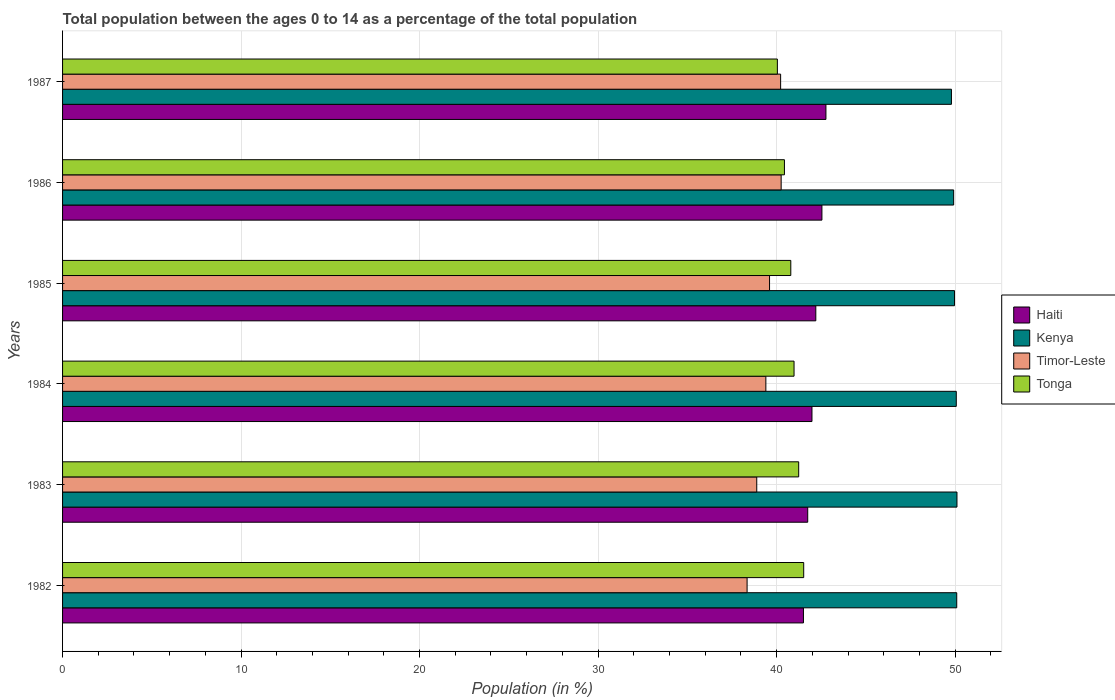How many different coloured bars are there?
Offer a very short reply. 4. How many groups of bars are there?
Make the answer very short. 6. What is the label of the 4th group of bars from the top?
Provide a succinct answer. 1984. In how many cases, is the number of bars for a given year not equal to the number of legend labels?
Your answer should be very brief. 0. What is the percentage of the population ages 0 to 14 in Timor-Leste in 1982?
Keep it short and to the point. 38.35. Across all years, what is the maximum percentage of the population ages 0 to 14 in Tonga?
Offer a terse response. 41.52. Across all years, what is the minimum percentage of the population ages 0 to 14 in Timor-Leste?
Offer a very short reply. 38.35. What is the total percentage of the population ages 0 to 14 in Kenya in the graph?
Keep it short and to the point. 299.94. What is the difference between the percentage of the population ages 0 to 14 in Kenya in 1986 and that in 1987?
Keep it short and to the point. 0.12. What is the difference between the percentage of the population ages 0 to 14 in Tonga in 1987 and the percentage of the population ages 0 to 14 in Kenya in 1985?
Ensure brevity in your answer.  -9.92. What is the average percentage of the population ages 0 to 14 in Timor-Leste per year?
Provide a short and direct response. 39.45. In the year 1984, what is the difference between the percentage of the population ages 0 to 14 in Tonga and percentage of the population ages 0 to 14 in Haiti?
Keep it short and to the point. -1. What is the ratio of the percentage of the population ages 0 to 14 in Kenya in 1984 to that in 1987?
Your answer should be compact. 1.01. Is the percentage of the population ages 0 to 14 in Tonga in 1984 less than that in 1986?
Your answer should be very brief. No. What is the difference between the highest and the second highest percentage of the population ages 0 to 14 in Tonga?
Offer a terse response. 0.28. What is the difference between the highest and the lowest percentage of the population ages 0 to 14 in Timor-Leste?
Give a very brief answer. 1.91. In how many years, is the percentage of the population ages 0 to 14 in Tonga greater than the average percentage of the population ages 0 to 14 in Tonga taken over all years?
Provide a succinct answer. 3. Is the sum of the percentage of the population ages 0 to 14 in Timor-Leste in 1984 and 1985 greater than the maximum percentage of the population ages 0 to 14 in Tonga across all years?
Offer a very short reply. Yes. What does the 4th bar from the top in 1987 represents?
Your answer should be compact. Haiti. What does the 1st bar from the bottom in 1984 represents?
Give a very brief answer. Haiti. How many years are there in the graph?
Ensure brevity in your answer.  6. Does the graph contain grids?
Your answer should be compact. Yes. Where does the legend appear in the graph?
Your answer should be compact. Center right. What is the title of the graph?
Your response must be concise. Total population between the ages 0 to 14 as a percentage of the total population. Does "Latvia" appear as one of the legend labels in the graph?
Make the answer very short. No. What is the label or title of the X-axis?
Your response must be concise. Population (in %). What is the Population (in %) in Haiti in 1982?
Your answer should be compact. 41.5. What is the Population (in %) in Kenya in 1982?
Your response must be concise. 50.09. What is the Population (in %) of Timor-Leste in 1982?
Keep it short and to the point. 38.35. What is the Population (in %) in Tonga in 1982?
Offer a terse response. 41.52. What is the Population (in %) in Haiti in 1983?
Ensure brevity in your answer.  41.74. What is the Population (in %) in Kenya in 1983?
Your answer should be compact. 50.1. What is the Population (in %) of Timor-Leste in 1983?
Offer a very short reply. 38.89. What is the Population (in %) of Tonga in 1983?
Ensure brevity in your answer.  41.24. What is the Population (in %) in Haiti in 1984?
Offer a terse response. 41.98. What is the Population (in %) of Kenya in 1984?
Make the answer very short. 50.07. What is the Population (in %) in Timor-Leste in 1984?
Your answer should be compact. 39.4. What is the Population (in %) of Tonga in 1984?
Your answer should be compact. 40.98. What is the Population (in %) of Haiti in 1985?
Offer a terse response. 42.2. What is the Population (in %) of Kenya in 1985?
Give a very brief answer. 49.97. What is the Population (in %) in Timor-Leste in 1985?
Your response must be concise. 39.6. What is the Population (in %) in Tonga in 1985?
Your answer should be very brief. 40.79. What is the Population (in %) of Haiti in 1986?
Keep it short and to the point. 42.54. What is the Population (in %) in Kenya in 1986?
Give a very brief answer. 49.92. What is the Population (in %) in Timor-Leste in 1986?
Give a very brief answer. 40.26. What is the Population (in %) in Tonga in 1986?
Your response must be concise. 40.44. What is the Population (in %) in Haiti in 1987?
Offer a very short reply. 42.76. What is the Population (in %) in Kenya in 1987?
Provide a succinct answer. 49.79. What is the Population (in %) in Timor-Leste in 1987?
Provide a succinct answer. 40.23. What is the Population (in %) in Tonga in 1987?
Your answer should be very brief. 40.04. Across all years, what is the maximum Population (in %) of Haiti?
Ensure brevity in your answer.  42.76. Across all years, what is the maximum Population (in %) in Kenya?
Provide a short and direct response. 50.1. Across all years, what is the maximum Population (in %) of Timor-Leste?
Give a very brief answer. 40.26. Across all years, what is the maximum Population (in %) of Tonga?
Your answer should be compact. 41.52. Across all years, what is the minimum Population (in %) in Haiti?
Give a very brief answer. 41.5. Across all years, what is the minimum Population (in %) in Kenya?
Ensure brevity in your answer.  49.79. Across all years, what is the minimum Population (in %) in Timor-Leste?
Provide a short and direct response. 38.35. Across all years, what is the minimum Population (in %) of Tonga?
Keep it short and to the point. 40.04. What is the total Population (in %) of Haiti in the graph?
Give a very brief answer. 252.73. What is the total Population (in %) in Kenya in the graph?
Provide a short and direct response. 299.94. What is the total Population (in %) of Timor-Leste in the graph?
Offer a terse response. 236.72. What is the total Population (in %) of Tonga in the graph?
Provide a short and direct response. 245.01. What is the difference between the Population (in %) of Haiti in 1982 and that in 1983?
Provide a succinct answer. -0.24. What is the difference between the Population (in %) in Kenya in 1982 and that in 1983?
Give a very brief answer. -0.01. What is the difference between the Population (in %) of Timor-Leste in 1982 and that in 1983?
Your response must be concise. -0.54. What is the difference between the Population (in %) in Tonga in 1982 and that in 1983?
Give a very brief answer. 0.28. What is the difference between the Population (in %) of Haiti in 1982 and that in 1984?
Keep it short and to the point. -0.48. What is the difference between the Population (in %) in Kenya in 1982 and that in 1984?
Keep it short and to the point. 0.03. What is the difference between the Population (in %) in Timor-Leste in 1982 and that in 1984?
Offer a very short reply. -1.05. What is the difference between the Population (in %) in Tonga in 1982 and that in 1984?
Keep it short and to the point. 0.54. What is the difference between the Population (in %) in Haiti in 1982 and that in 1985?
Make the answer very short. -0.69. What is the difference between the Population (in %) in Kenya in 1982 and that in 1985?
Offer a very short reply. 0.12. What is the difference between the Population (in %) in Timor-Leste in 1982 and that in 1985?
Offer a very short reply. -1.26. What is the difference between the Population (in %) in Tonga in 1982 and that in 1985?
Make the answer very short. 0.72. What is the difference between the Population (in %) of Haiti in 1982 and that in 1986?
Your answer should be very brief. -1.03. What is the difference between the Population (in %) of Kenya in 1982 and that in 1986?
Offer a terse response. 0.17. What is the difference between the Population (in %) of Timor-Leste in 1982 and that in 1986?
Your response must be concise. -1.91. What is the difference between the Population (in %) of Tonga in 1982 and that in 1986?
Ensure brevity in your answer.  1.08. What is the difference between the Population (in %) of Haiti in 1982 and that in 1987?
Provide a succinct answer. -1.26. What is the difference between the Population (in %) in Kenya in 1982 and that in 1987?
Give a very brief answer. 0.3. What is the difference between the Population (in %) in Timor-Leste in 1982 and that in 1987?
Your answer should be compact. -1.88. What is the difference between the Population (in %) of Tonga in 1982 and that in 1987?
Provide a short and direct response. 1.47. What is the difference between the Population (in %) of Haiti in 1983 and that in 1984?
Keep it short and to the point. -0.24. What is the difference between the Population (in %) in Kenya in 1983 and that in 1984?
Your answer should be compact. 0.04. What is the difference between the Population (in %) in Timor-Leste in 1983 and that in 1984?
Provide a succinct answer. -0.51. What is the difference between the Population (in %) of Tonga in 1983 and that in 1984?
Keep it short and to the point. 0.26. What is the difference between the Population (in %) in Haiti in 1983 and that in 1985?
Give a very brief answer. -0.45. What is the difference between the Population (in %) in Kenya in 1983 and that in 1985?
Your answer should be compact. 0.14. What is the difference between the Population (in %) of Timor-Leste in 1983 and that in 1985?
Ensure brevity in your answer.  -0.72. What is the difference between the Population (in %) in Tonga in 1983 and that in 1985?
Give a very brief answer. 0.44. What is the difference between the Population (in %) of Haiti in 1983 and that in 1986?
Give a very brief answer. -0.79. What is the difference between the Population (in %) of Kenya in 1983 and that in 1986?
Provide a short and direct response. 0.19. What is the difference between the Population (in %) of Timor-Leste in 1983 and that in 1986?
Your response must be concise. -1.37. What is the difference between the Population (in %) in Tonga in 1983 and that in 1986?
Your answer should be very brief. 0.8. What is the difference between the Population (in %) in Haiti in 1983 and that in 1987?
Your answer should be very brief. -1.02. What is the difference between the Population (in %) in Kenya in 1983 and that in 1987?
Provide a succinct answer. 0.31. What is the difference between the Population (in %) of Timor-Leste in 1983 and that in 1987?
Offer a very short reply. -1.34. What is the difference between the Population (in %) in Tonga in 1983 and that in 1987?
Provide a succinct answer. 1.19. What is the difference between the Population (in %) in Haiti in 1984 and that in 1985?
Offer a terse response. -0.21. What is the difference between the Population (in %) of Kenya in 1984 and that in 1985?
Your answer should be very brief. 0.1. What is the difference between the Population (in %) of Timor-Leste in 1984 and that in 1985?
Ensure brevity in your answer.  -0.21. What is the difference between the Population (in %) in Tonga in 1984 and that in 1985?
Keep it short and to the point. 0.18. What is the difference between the Population (in %) of Haiti in 1984 and that in 1986?
Offer a terse response. -0.56. What is the difference between the Population (in %) of Kenya in 1984 and that in 1986?
Make the answer very short. 0.15. What is the difference between the Population (in %) in Timor-Leste in 1984 and that in 1986?
Provide a succinct answer. -0.86. What is the difference between the Population (in %) of Tonga in 1984 and that in 1986?
Make the answer very short. 0.54. What is the difference between the Population (in %) of Haiti in 1984 and that in 1987?
Make the answer very short. -0.78. What is the difference between the Population (in %) of Kenya in 1984 and that in 1987?
Offer a very short reply. 0.27. What is the difference between the Population (in %) of Timor-Leste in 1984 and that in 1987?
Your response must be concise. -0.83. What is the difference between the Population (in %) of Tonga in 1984 and that in 1987?
Provide a short and direct response. 0.93. What is the difference between the Population (in %) in Haiti in 1985 and that in 1986?
Make the answer very short. -0.34. What is the difference between the Population (in %) in Kenya in 1985 and that in 1986?
Provide a succinct answer. 0.05. What is the difference between the Population (in %) in Timor-Leste in 1985 and that in 1986?
Provide a short and direct response. -0.65. What is the difference between the Population (in %) in Tonga in 1985 and that in 1986?
Keep it short and to the point. 0.36. What is the difference between the Population (in %) of Haiti in 1985 and that in 1987?
Ensure brevity in your answer.  -0.57. What is the difference between the Population (in %) in Kenya in 1985 and that in 1987?
Your answer should be very brief. 0.17. What is the difference between the Population (in %) of Timor-Leste in 1985 and that in 1987?
Ensure brevity in your answer.  -0.62. What is the difference between the Population (in %) in Tonga in 1985 and that in 1987?
Your response must be concise. 0.75. What is the difference between the Population (in %) of Haiti in 1986 and that in 1987?
Offer a terse response. -0.23. What is the difference between the Population (in %) in Kenya in 1986 and that in 1987?
Offer a very short reply. 0.12. What is the difference between the Population (in %) in Timor-Leste in 1986 and that in 1987?
Offer a terse response. 0.03. What is the difference between the Population (in %) of Tonga in 1986 and that in 1987?
Make the answer very short. 0.4. What is the difference between the Population (in %) of Haiti in 1982 and the Population (in %) of Kenya in 1983?
Your response must be concise. -8.6. What is the difference between the Population (in %) of Haiti in 1982 and the Population (in %) of Timor-Leste in 1983?
Provide a succinct answer. 2.62. What is the difference between the Population (in %) of Haiti in 1982 and the Population (in %) of Tonga in 1983?
Your answer should be compact. 0.27. What is the difference between the Population (in %) of Kenya in 1982 and the Population (in %) of Timor-Leste in 1983?
Make the answer very short. 11.2. What is the difference between the Population (in %) in Kenya in 1982 and the Population (in %) in Tonga in 1983?
Your response must be concise. 8.85. What is the difference between the Population (in %) of Timor-Leste in 1982 and the Population (in %) of Tonga in 1983?
Your answer should be compact. -2.89. What is the difference between the Population (in %) of Haiti in 1982 and the Population (in %) of Kenya in 1984?
Make the answer very short. -8.56. What is the difference between the Population (in %) of Haiti in 1982 and the Population (in %) of Timor-Leste in 1984?
Provide a succinct answer. 2.11. What is the difference between the Population (in %) in Haiti in 1982 and the Population (in %) in Tonga in 1984?
Your response must be concise. 0.53. What is the difference between the Population (in %) in Kenya in 1982 and the Population (in %) in Timor-Leste in 1984?
Keep it short and to the point. 10.69. What is the difference between the Population (in %) of Kenya in 1982 and the Population (in %) of Tonga in 1984?
Keep it short and to the point. 9.11. What is the difference between the Population (in %) of Timor-Leste in 1982 and the Population (in %) of Tonga in 1984?
Your answer should be compact. -2.63. What is the difference between the Population (in %) of Haiti in 1982 and the Population (in %) of Kenya in 1985?
Make the answer very short. -8.46. What is the difference between the Population (in %) in Haiti in 1982 and the Population (in %) in Timor-Leste in 1985?
Your response must be concise. 1.9. What is the difference between the Population (in %) of Haiti in 1982 and the Population (in %) of Tonga in 1985?
Offer a terse response. 0.71. What is the difference between the Population (in %) in Kenya in 1982 and the Population (in %) in Timor-Leste in 1985?
Offer a very short reply. 10.49. What is the difference between the Population (in %) in Kenya in 1982 and the Population (in %) in Tonga in 1985?
Offer a terse response. 9.3. What is the difference between the Population (in %) in Timor-Leste in 1982 and the Population (in %) in Tonga in 1985?
Make the answer very short. -2.45. What is the difference between the Population (in %) in Haiti in 1982 and the Population (in %) in Kenya in 1986?
Your response must be concise. -8.41. What is the difference between the Population (in %) in Haiti in 1982 and the Population (in %) in Timor-Leste in 1986?
Keep it short and to the point. 1.25. What is the difference between the Population (in %) of Haiti in 1982 and the Population (in %) of Tonga in 1986?
Offer a terse response. 1.07. What is the difference between the Population (in %) of Kenya in 1982 and the Population (in %) of Timor-Leste in 1986?
Ensure brevity in your answer.  9.84. What is the difference between the Population (in %) of Kenya in 1982 and the Population (in %) of Tonga in 1986?
Keep it short and to the point. 9.65. What is the difference between the Population (in %) in Timor-Leste in 1982 and the Population (in %) in Tonga in 1986?
Make the answer very short. -2.09. What is the difference between the Population (in %) in Haiti in 1982 and the Population (in %) in Kenya in 1987?
Keep it short and to the point. -8.29. What is the difference between the Population (in %) of Haiti in 1982 and the Population (in %) of Timor-Leste in 1987?
Offer a terse response. 1.28. What is the difference between the Population (in %) in Haiti in 1982 and the Population (in %) in Tonga in 1987?
Ensure brevity in your answer.  1.46. What is the difference between the Population (in %) of Kenya in 1982 and the Population (in %) of Timor-Leste in 1987?
Your response must be concise. 9.87. What is the difference between the Population (in %) in Kenya in 1982 and the Population (in %) in Tonga in 1987?
Provide a succinct answer. 10.05. What is the difference between the Population (in %) of Timor-Leste in 1982 and the Population (in %) of Tonga in 1987?
Give a very brief answer. -1.7. What is the difference between the Population (in %) in Haiti in 1983 and the Population (in %) in Kenya in 1984?
Your answer should be very brief. -8.32. What is the difference between the Population (in %) of Haiti in 1983 and the Population (in %) of Timor-Leste in 1984?
Provide a succinct answer. 2.35. What is the difference between the Population (in %) of Haiti in 1983 and the Population (in %) of Tonga in 1984?
Your answer should be very brief. 0.77. What is the difference between the Population (in %) of Kenya in 1983 and the Population (in %) of Timor-Leste in 1984?
Ensure brevity in your answer.  10.71. What is the difference between the Population (in %) of Kenya in 1983 and the Population (in %) of Tonga in 1984?
Provide a succinct answer. 9.13. What is the difference between the Population (in %) of Timor-Leste in 1983 and the Population (in %) of Tonga in 1984?
Your response must be concise. -2.09. What is the difference between the Population (in %) of Haiti in 1983 and the Population (in %) of Kenya in 1985?
Your response must be concise. -8.22. What is the difference between the Population (in %) of Haiti in 1983 and the Population (in %) of Timor-Leste in 1985?
Offer a terse response. 2.14. What is the difference between the Population (in %) in Haiti in 1983 and the Population (in %) in Tonga in 1985?
Keep it short and to the point. 0.95. What is the difference between the Population (in %) in Kenya in 1983 and the Population (in %) in Timor-Leste in 1985?
Keep it short and to the point. 10.5. What is the difference between the Population (in %) of Kenya in 1983 and the Population (in %) of Tonga in 1985?
Your answer should be compact. 9.31. What is the difference between the Population (in %) of Timor-Leste in 1983 and the Population (in %) of Tonga in 1985?
Provide a succinct answer. -1.91. What is the difference between the Population (in %) in Haiti in 1983 and the Population (in %) in Kenya in 1986?
Your answer should be very brief. -8.18. What is the difference between the Population (in %) in Haiti in 1983 and the Population (in %) in Timor-Leste in 1986?
Your answer should be very brief. 1.49. What is the difference between the Population (in %) of Haiti in 1983 and the Population (in %) of Tonga in 1986?
Offer a very short reply. 1.3. What is the difference between the Population (in %) in Kenya in 1983 and the Population (in %) in Timor-Leste in 1986?
Make the answer very short. 9.85. What is the difference between the Population (in %) of Kenya in 1983 and the Population (in %) of Tonga in 1986?
Provide a succinct answer. 9.67. What is the difference between the Population (in %) in Timor-Leste in 1983 and the Population (in %) in Tonga in 1986?
Make the answer very short. -1.55. What is the difference between the Population (in %) of Haiti in 1983 and the Population (in %) of Kenya in 1987?
Provide a succinct answer. -8.05. What is the difference between the Population (in %) of Haiti in 1983 and the Population (in %) of Timor-Leste in 1987?
Your answer should be very brief. 1.52. What is the difference between the Population (in %) in Haiti in 1983 and the Population (in %) in Tonga in 1987?
Make the answer very short. 1.7. What is the difference between the Population (in %) of Kenya in 1983 and the Population (in %) of Timor-Leste in 1987?
Your answer should be very brief. 9.88. What is the difference between the Population (in %) in Kenya in 1983 and the Population (in %) in Tonga in 1987?
Make the answer very short. 10.06. What is the difference between the Population (in %) in Timor-Leste in 1983 and the Population (in %) in Tonga in 1987?
Your answer should be very brief. -1.15. What is the difference between the Population (in %) of Haiti in 1984 and the Population (in %) of Kenya in 1985?
Provide a succinct answer. -7.99. What is the difference between the Population (in %) of Haiti in 1984 and the Population (in %) of Timor-Leste in 1985?
Your response must be concise. 2.38. What is the difference between the Population (in %) in Haiti in 1984 and the Population (in %) in Tonga in 1985?
Your answer should be very brief. 1.19. What is the difference between the Population (in %) of Kenya in 1984 and the Population (in %) of Timor-Leste in 1985?
Offer a very short reply. 10.46. What is the difference between the Population (in %) in Kenya in 1984 and the Population (in %) in Tonga in 1985?
Keep it short and to the point. 9.27. What is the difference between the Population (in %) in Timor-Leste in 1984 and the Population (in %) in Tonga in 1985?
Your answer should be very brief. -1.4. What is the difference between the Population (in %) in Haiti in 1984 and the Population (in %) in Kenya in 1986?
Provide a short and direct response. -7.94. What is the difference between the Population (in %) in Haiti in 1984 and the Population (in %) in Timor-Leste in 1986?
Offer a very short reply. 1.73. What is the difference between the Population (in %) in Haiti in 1984 and the Population (in %) in Tonga in 1986?
Ensure brevity in your answer.  1.54. What is the difference between the Population (in %) in Kenya in 1984 and the Population (in %) in Timor-Leste in 1986?
Make the answer very short. 9.81. What is the difference between the Population (in %) of Kenya in 1984 and the Population (in %) of Tonga in 1986?
Your response must be concise. 9.63. What is the difference between the Population (in %) in Timor-Leste in 1984 and the Population (in %) in Tonga in 1986?
Your answer should be very brief. -1.04. What is the difference between the Population (in %) in Haiti in 1984 and the Population (in %) in Kenya in 1987?
Provide a short and direct response. -7.81. What is the difference between the Population (in %) in Haiti in 1984 and the Population (in %) in Timor-Leste in 1987?
Offer a very short reply. 1.76. What is the difference between the Population (in %) in Haiti in 1984 and the Population (in %) in Tonga in 1987?
Provide a succinct answer. 1.94. What is the difference between the Population (in %) of Kenya in 1984 and the Population (in %) of Timor-Leste in 1987?
Your response must be concise. 9.84. What is the difference between the Population (in %) in Kenya in 1984 and the Population (in %) in Tonga in 1987?
Offer a very short reply. 10.02. What is the difference between the Population (in %) in Timor-Leste in 1984 and the Population (in %) in Tonga in 1987?
Keep it short and to the point. -0.64. What is the difference between the Population (in %) of Haiti in 1985 and the Population (in %) of Kenya in 1986?
Provide a short and direct response. -7.72. What is the difference between the Population (in %) in Haiti in 1985 and the Population (in %) in Timor-Leste in 1986?
Offer a terse response. 1.94. What is the difference between the Population (in %) of Haiti in 1985 and the Population (in %) of Tonga in 1986?
Keep it short and to the point. 1.76. What is the difference between the Population (in %) of Kenya in 1985 and the Population (in %) of Timor-Leste in 1986?
Provide a short and direct response. 9.71. What is the difference between the Population (in %) of Kenya in 1985 and the Population (in %) of Tonga in 1986?
Your answer should be very brief. 9.53. What is the difference between the Population (in %) of Timor-Leste in 1985 and the Population (in %) of Tonga in 1986?
Your response must be concise. -0.83. What is the difference between the Population (in %) of Haiti in 1985 and the Population (in %) of Kenya in 1987?
Ensure brevity in your answer.  -7.6. What is the difference between the Population (in %) of Haiti in 1985 and the Population (in %) of Timor-Leste in 1987?
Your answer should be compact. 1.97. What is the difference between the Population (in %) in Haiti in 1985 and the Population (in %) in Tonga in 1987?
Your response must be concise. 2.15. What is the difference between the Population (in %) in Kenya in 1985 and the Population (in %) in Timor-Leste in 1987?
Provide a succinct answer. 9.74. What is the difference between the Population (in %) in Kenya in 1985 and the Population (in %) in Tonga in 1987?
Your answer should be very brief. 9.92. What is the difference between the Population (in %) in Timor-Leste in 1985 and the Population (in %) in Tonga in 1987?
Your answer should be very brief. -0.44. What is the difference between the Population (in %) of Haiti in 1986 and the Population (in %) of Kenya in 1987?
Offer a terse response. -7.26. What is the difference between the Population (in %) in Haiti in 1986 and the Population (in %) in Timor-Leste in 1987?
Ensure brevity in your answer.  2.31. What is the difference between the Population (in %) in Haiti in 1986 and the Population (in %) in Tonga in 1987?
Keep it short and to the point. 2.5. What is the difference between the Population (in %) in Kenya in 1986 and the Population (in %) in Timor-Leste in 1987?
Keep it short and to the point. 9.69. What is the difference between the Population (in %) in Kenya in 1986 and the Population (in %) in Tonga in 1987?
Provide a short and direct response. 9.88. What is the difference between the Population (in %) of Timor-Leste in 1986 and the Population (in %) of Tonga in 1987?
Give a very brief answer. 0.21. What is the average Population (in %) in Haiti per year?
Your response must be concise. 42.12. What is the average Population (in %) of Kenya per year?
Your answer should be very brief. 49.99. What is the average Population (in %) of Timor-Leste per year?
Your response must be concise. 39.45. What is the average Population (in %) in Tonga per year?
Provide a succinct answer. 40.83. In the year 1982, what is the difference between the Population (in %) of Haiti and Population (in %) of Kenya?
Offer a terse response. -8.59. In the year 1982, what is the difference between the Population (in %) of Haiti and Population (in %) of Timor-Leste?
Ensure brevity in your answer.  3.16. In the year 1982, what is the difference between the Population (in %) in Haiti and Population (in %) in Tonga?
Make the answer very short. -0.01. In the year 1982, what is the difference between the Population (in %) in Kenya and Population (in %) in Timor-Leste?
Offer a terse response. 11.74. In the year 1982, what is the difference between the Population (in %) of Kenya and Population (in %) of Tonga?
Ensure brevity in your answer.  8.57. In the year 1982, what is the difference between the Population (in %) of Timor-Leste and Population (in %) of Tonga?
Offer a terse response. -3.17. In the year 1983, what is the difference between the Population (in %) of Haiti and Population (in %) of Kenya?
Keep it short and to the point. -8.36. In the year 1983, what is the difference between the Population (in %) in Haiti and Population (in %) in Timor-Leste?
Make the answer very short. 2.86. In the year 1983, what is the difference between the Population (in %) of Haiti and Population (in %) of Tonga?
Your response must be concise. 0.51. In the year 1983, what is the difference between the Population (in %) in Kenya and Population (in %) in Timor-Leste?
Your answer should be very brief. 11.22. In the year 1983, what is the difference between the Population (in %) of Kenya and Population (in %) of Tonga?
Ensure brevity in your answer.  8.87. In the year 1983, what is the difference between the Population (in %) of Timor-Leste and Population (in %) of Tonga?
Give a very brief answer. -2.35. In the year 1984, what is the difference between the Population (in %) in Haiti and Population (in %) in Kenya?
Ensure brevity in your answer.  -8.08. In the year 1984, what is the difference between the Population (in %) in Haiti and Population (in %) in Timor-Leste?
Your response must be concise. 2.58. In the year 1984, what is the difference between the Population (in %) in Kenya and Population (in %) in Timor-Leste?
Your answer should be very brief. 10.67. In the year 1984, what is the difference between the Population (in %) of Kenya and Population (in %) of Tonga?
Offer a terse response. 9.09. In the year 1984, what is the difference between the Population (in %) in Timor-Leste and Population (in %) in Tonga?
Make the answer very short. -1.58. In the year 1985, what is the difference between the Population (in %) in Haiti and Population (in %) in Kenya?
Keep it short and to the point. -7.77. In the year 1985, what is the difference between the Population (in %) of Haiti and Population (in %) of Timor-Leste?
Your response must be concise. 2.59. In the year 1985, what is the difference between the Population (in %) in Haiti and Population (in %) in Tonga?
Give a very brief answer. 1.4. In the year 1985, what is the difference between the Population (in %) of Kenya and Population (in %) of Timor-Leste?
Your answer should be very brief. 10.36. In the year 1985, what is the difference between the Population (in %) of Kenya and Population (in %) of Tonga?
Offer a terse response. 9.17. In the year 1985, what is the difference between the Population (in %) of Timor-Leste and Population (in %) of Tonga?
Give a very brief answer. -1.19. In the year 1986, what is the difference between the Population (in %) in Haiti and Population (in %) in Kenya?
Your answer should be very brief. -7.38. In the year 1986, what is the difference between the Population (in %) in Haiti and Population (in %) in Timor-Leste?
Your answer should be very brief. 2.28. In the year 1986, what is the difference between the Population (in %) of Haiti and Population (in %) of Tonga?
Ensure brevity in your answer.  2.1. In the year 1986, what is the difference between the Population (in %) in Kenya and Population (in %) in Timor-Leste?
Make the answer very short. 9.66. In the year 1986, what is the difference between the Population (in %) of Kenya and Population (in %) of Tonga?
Your answer should be very brief. 9.48. In the year 1986, what is the difference between the Population (in %) in Timor-Leste and Population (in %) in Tonga?
Keep it short and to the point. -0.18. In the year 1987, what is the difference between the Population (in %) of Haiti and Population (in %) of Kenya?
Your response must be concise. -7.03. In the year 1987, what is the difference between the Population (in %) of Haiti and Population (in %) of Timor-Leste?
Your answer should be compact. 2.54. In the year 1987, what is the difference between the Population (in %) in Haiti and Population (in %) in Tonga?
Provide a succinct answer. 2.72. In the year 1987, what is the difference between the Population (in %) of Kenya and Population (in %) of Timor-Leste?
Ensure brevity in your answer.  9.57. In the year 1987, what is the difference between the Population (in %) of Kenya and Population (in %) of Tonga?
Your answer should be very brief. 9.75. In the year 1987, what is the difference between the Population (in %) of Timor-Leste and Population (in %) of Tonga?
Ensure brevity in your answer.  0.18. What is the ratio of the Population (in %) of Haiti in 1982 to that in 1983?
Ensure brevity in your answer.  0.99. What is the ratio of the Population (in %) of Timor-Leste in 1982 to that in 1983?
Keep it short and to the point. 0.99. What is the ratio of the Population (in %) in Tonga in 1982 to that in 1983?
Give a very brief answer. 1.01. What is the ratio of the Population (in %) in Kenya in 1982 to that in 1984?
Offer a very short reply. 1. What is the ratio of the Population (in %) of Timor-Leste in 1982 to that in 1984?
Your answer should be compact. 0.97. What is the ratio of the Population (in %) in Tonga in 1982 to that in 1984?
Your response must be concise. 1.01. What is the ratio of the Population (in %) in Haiti in 1982 to that in 1985?
Offer a very short reply. 0.98. What is the ratio of the Population (in %) in Kenya in 1982 to that in 1985?
Provide a succinct answer. 1. What is the ratio of the Population (in %) in Timor-Leste in 1982 to that in 1985?
Your response must be concise. 0.97. What is the ratio of the Population (in %) in Tonga in 1982 to that in 1985?
Keep it short and to the point. 1.02. What is the ratio of the Population (in %) of Haiti in 1982 to that in 1986?
Provide a succinct answer. 0.98. What is the ratio of the Population (in %) of Timor-Leste in 1982 to that in 1986?
Offer a very short reply. 0.95. What is the ratio of the Population (in %) in Tonga in 1982 to that in 1986?
Ensure brevity in your answer.  1.03. What is the ratio of the Population (in %) of Haiti in 1982 to that in 1987?
Make the answer very short. 0.97. What is the ratio of the Population (in %) of Kenya in 1982 to that in 1987?
Provide a short and direct response. 1.01. What is the ratio of the Population (in %) of Timor-Leste in 1982 to that in 1987?
Offer a terse response. 0.95. What is the ratio of the Population (in %) in Tonga in 1982 to that in 1987?
Offer a terse response. 1.04. What is the ratio of the Population (in %) in Kenya in 1983 to that in 1984?
Make the answer very short. 1. What is the ratio of the Population (in %) in Timor-Leste in 1983 to that in 1984?
Offer a terse response. 0.99. What is the ratio of the Population (in %) of Tonga in 1983 to that in 1984?
Ensure brevity in your answer.  1.01. What is the ratio of the Population (in %) in Haiti in 1983 to that in 1985?
Provide a short and direct response. 0.99. What is the ratio of the Population (in %) in Timor-Leste in 1983 to that in 1985?
Give a very brief answer. 0.98. What is the ratio of the Population (in %) in Tonga in 1983 to that in 1985?
Offer a very short reply. 1.01. What is the ratio of the Population (in %) in Haiti in 1983 to that in 1986?
Offer a terse response. 0.98. What is the ratio of the Population (in %) in Timor-Leste in 1983 to that in 1986?
Keep it short and to the point. 0.97. What is the ratio of the Population (in %) in Tonga in 1983 to that in 1986?
Make the answer very short. 1.02. What is the ratio of the Population (in %) of Haiti in 1983 to that in 1987?
Your response must be concise. 0.98. What is the ratio of the Population (in %) in Kenya in 1983 to that in 1987?
Offer a very short reply. 1.01. What is the ratio of the Population (in %) in Timor-Leste in 1983 to that in 1987?
Your response must be concise. 0.97. What is the ratio of the Population (in %) in Tonga in 1983 to that in 1987?
Offer a very short reply. 1.03. What is the ratio of the Population (in %) of Kenya in 1984 to that in 1985?
Offer a terse response. 1. What is the ratio of the Population (in %) of Tonga in 1984 to that in 1985?
Provide a short and direct response. 1. What is the ratio of the Population (in %) of Haiti in 1984 to that in 1986?
Your answer should be compact. 0.99. What is the ratio of the Population (in %) of Timor-Leste in 1984 to that in 1986?
Offer a very short reply. 0.98. What is the ratio of the Population (in %) of Tonga in 1984 to that in 1986?
Your answer should be very brief. 1.01. What is the ratio of the Population (in %) of Haiti in 1984 to that in 1987?
Provide a succinct answer. 0.98. What is the ratio of the Population (in %) of Kenya in 1984 to that in 1987?
Provide a succinct answer. 1.01. What is the ratio of the Population (in %) in Timor-Leste in 1984 to that in 1987?
Your answer should be very brief. 0.98. What is the ratio of the Population (in %) of Tonga in 1984 to that in 1987?
Your answer should be very brief. 1.02. What is the ratio of the Population (in %) of Timor-Leste in 1985 to that in 1986?
Provide a succinct answer. 0.98. What is the ratio of the Population (in %) of Tonga in 1985 to that in 1986?
Give a very brief answer. 1.01. What is the ratio of the Population (in %) of Haiti in 1985 to that in 1987?
Your response must be concise. 0.99. What is the ratio of the Population (in %) of Kenya in 1985 to that in 1987?
Provide a short and direct response. 1. What is the ratio of the Population (in %) in Timor-Leste in 1985 to that in 1987?
Your response must be concise. 0.98. What is the ratio of the Population (in %) in Tonga in 1985 to that in 1987?
Offer a very short reply. 1.02. What is the ratio of the Population (in %) of Timor-Leste in 1986 to that in 1987?
Offer a very short reply. 1. What is the ratio of the Population (in %) of Tonga in 1986 to that in 1987?
Provide a succinct answer. 1.01. What is the difference between the highest and the second highest Population (in %) of Haiti?
Provide a short and direct response. 0.23. What is the difference between the highest and the second highest Population (in %) in Kenya?
Offer a terse response. 0.01. What is the difference between the highest and the second highest Population (in %) in Timor-Leste?
Your answer should be compact. 0.03. What is the difference between the highest and the second highest Population (in %) in Tonga?
Ensure brevity in your answer.  0.28. What is the difference between the highest and the lowest Population (in %) of Haiti?
Your answer should be very brief. 1.26. What is the difference between the highest and the lowest Population (in %) of Kenya?
Ensure brevity in your answer.  0.31. What is the difference between the highest and the lowest Population (in %) in Timor-Leste?
Provide a short and direct response. 1.91. What is the difference between the highest and the lowest Population (in %) in Tonga?
Your response must be concise. 1.47. 